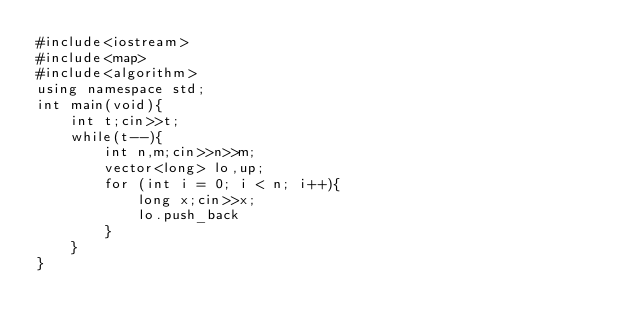Convert code to text. <code><loc_0><loc_0><loc_500><loc_500><_C++_>#include<iostream>
#include<map>
#include<algorithm>
using namespace std;
int main(void){
	int t;cin>>t;
	while(t--){
		int n,m;cin>>n>>m;
		vector<long> lo,up;
		for (int i = 0; i < n; i++){
			long x;cin>>x;
			lo.push_back
		}
	}
}</code> 